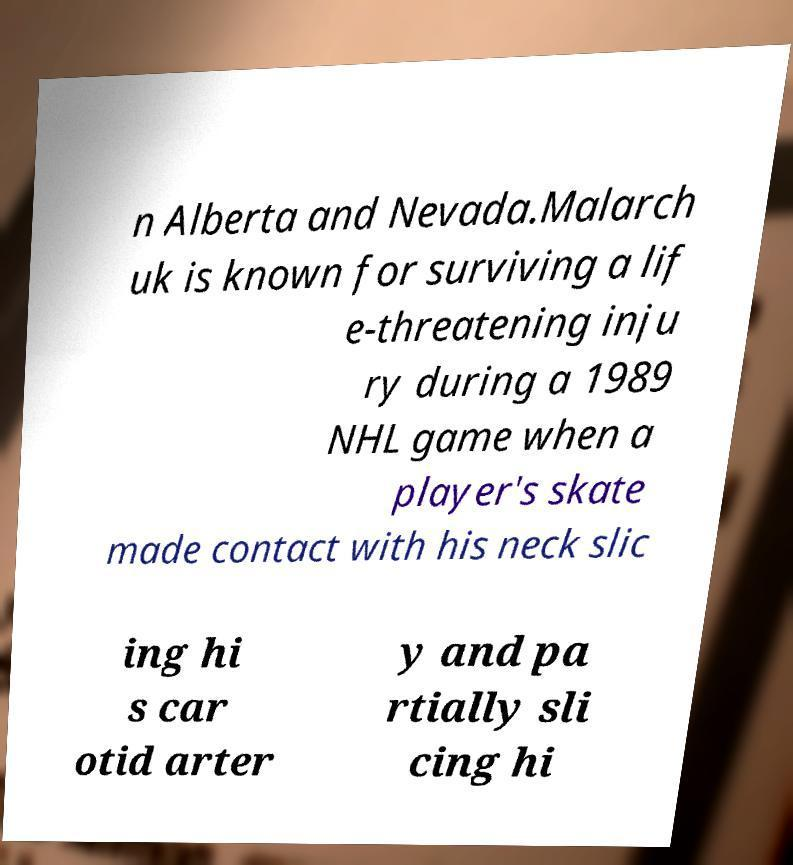Please read and relay the text visible in this image. What does it say? n Alberta and Nevada.Malarch uk is known for surviving a lif e-threatening inju ry during a 1989 NHL game when a player's skate made contact with his neck slic ing hi s car otid arter y and pa rtially sli cing hi 